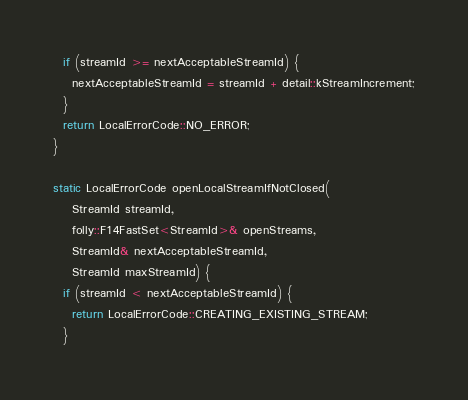Convert code to text. <code><loc_0><loc_0><loc_500><loc_500><_C++_>
  if (streamId >= nextAcceptableStreamId) {
    nextAcceptableStreamId = streamId + detail::kStreamIncrement;
  }
  return LocalErrorCode::NO_ERROR;
}

static LocalErrorCode openLocalStreamIfNotClosed(
    StreamId streamId,
    folly::F14FastSet<StreamId>& openStreams,
    StreamId& nextAcceptableStreamId,
    StreamId maxStreamId) {
  if (streamId < nextAcceptableStreamId) {
    return LocalErrorCode::CREATING_EXISTING_STREAM;
  }</code> 